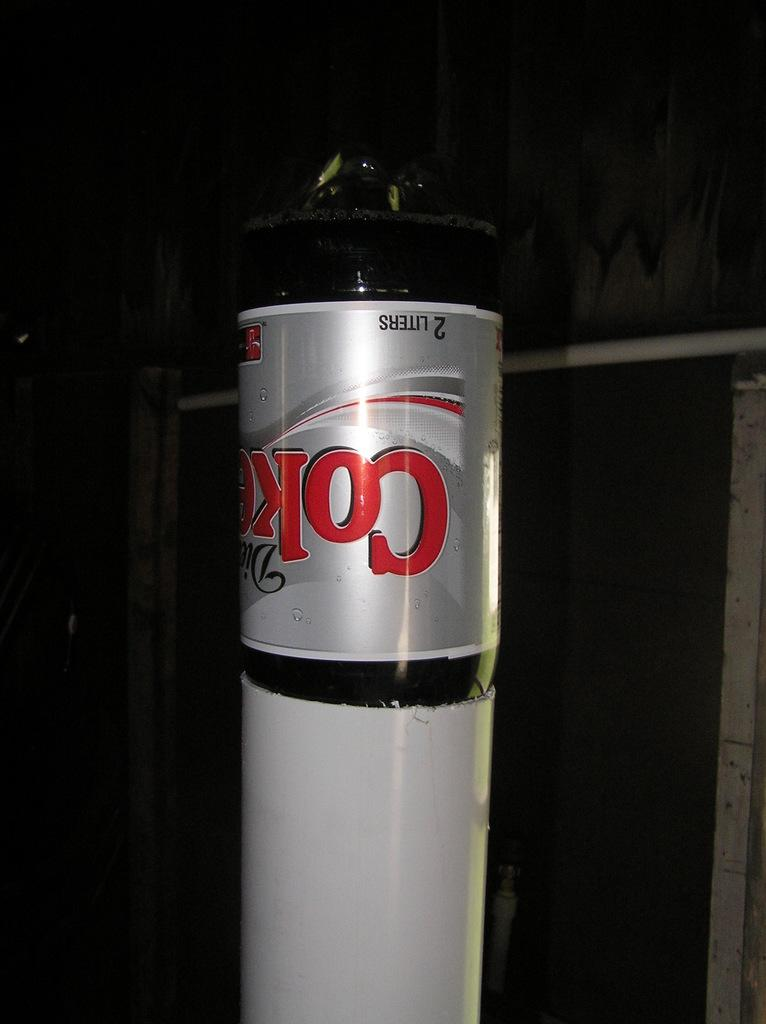<image>
Relay a brief, clear account of the picture shown. A 2-liter of diet coke is upside down in a white object. 